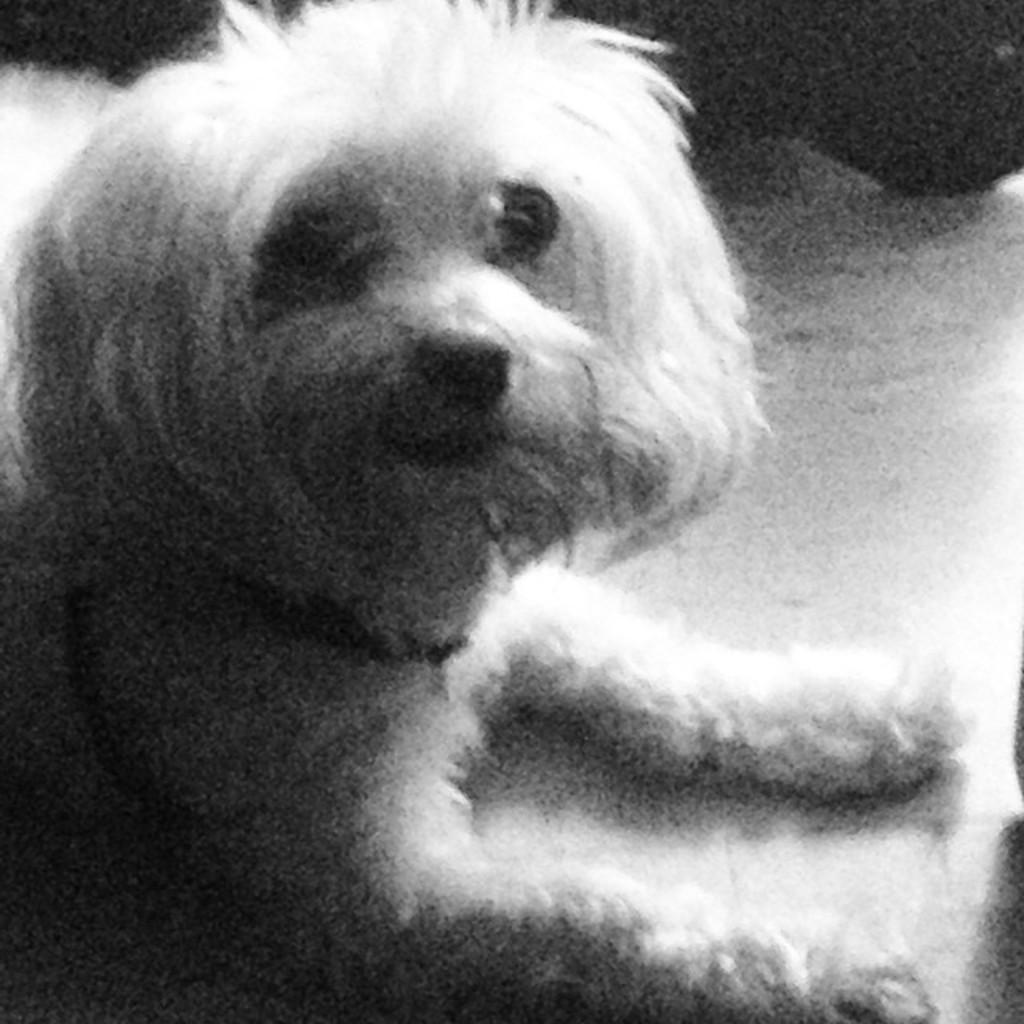What animal is present in the image? There is a dog in the image. What is the dog doing in the image? The dog is sitting on a surface. What is the color scheme of the image? The image is in black and white. What type of chain is the dog wearing in the image? There is no chain present in the image; the dog is not wearing any accessories. 